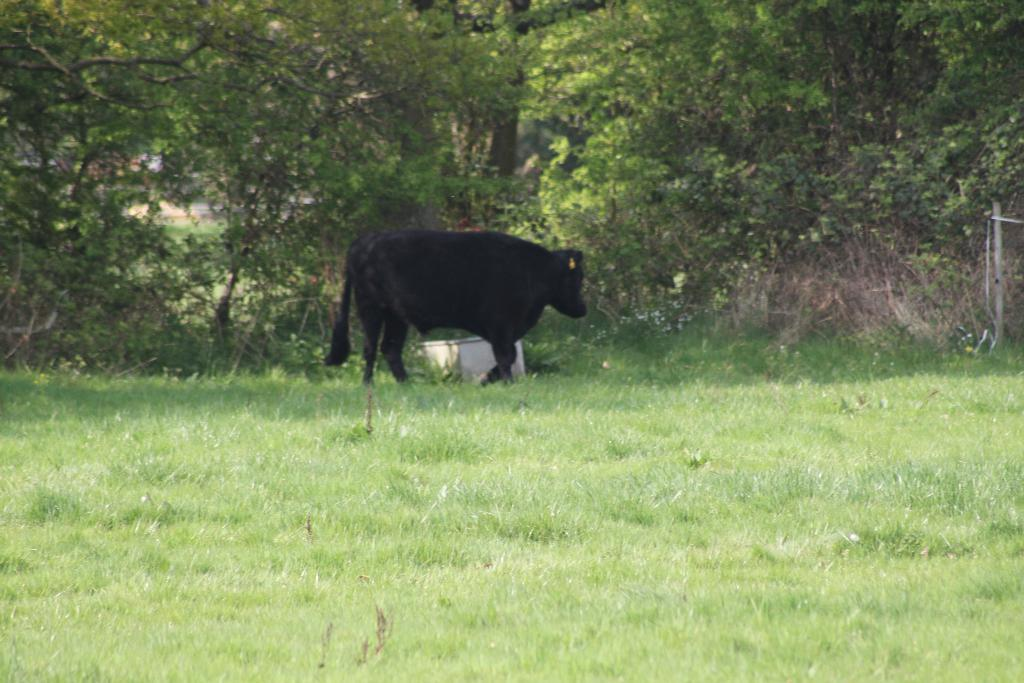What is the main subject in the center of the image? There is an animal in the center of the image. What is the color of the animal? The animal is black in color. What type of vegetation is present on the ground in the front of the image? There is grass on the ground in the front of the image. What can be seen in the background of the image? There are trees in the background of the image. What type of skirt is the animal wearing in the image? The animal is not wearing a skirt in the image, as animals do not wear clothing. 